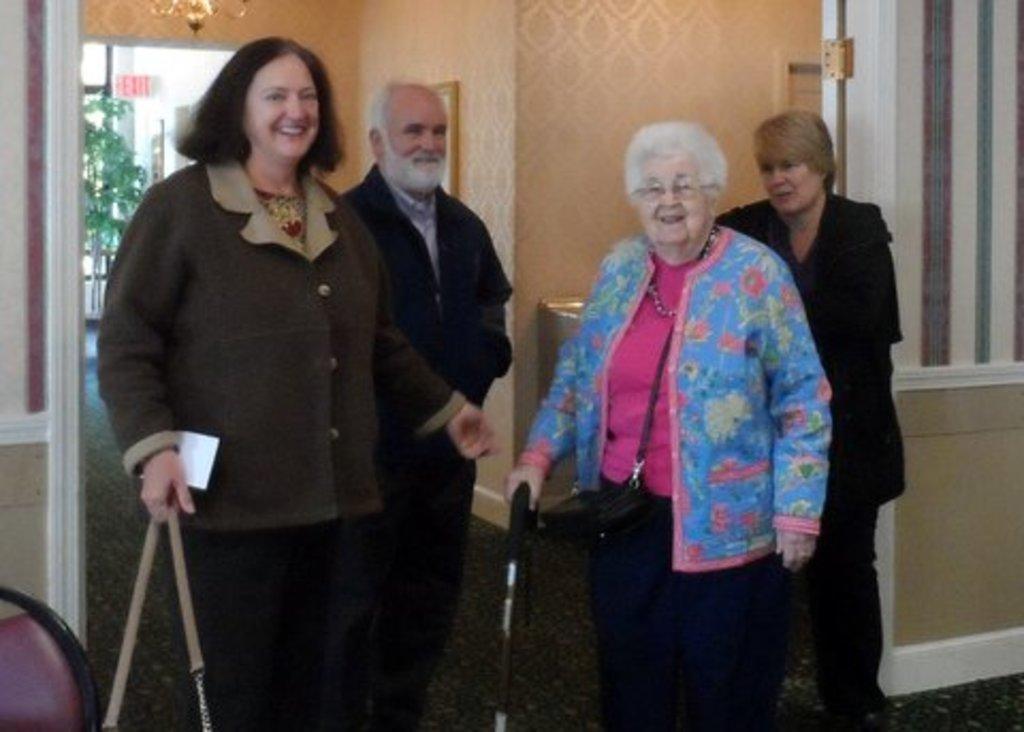How would you summarize this image in a sentence or two? In this picture we can observe some people. There are women and a man. All of them are smiling. In the background we can observe a green color wall. 